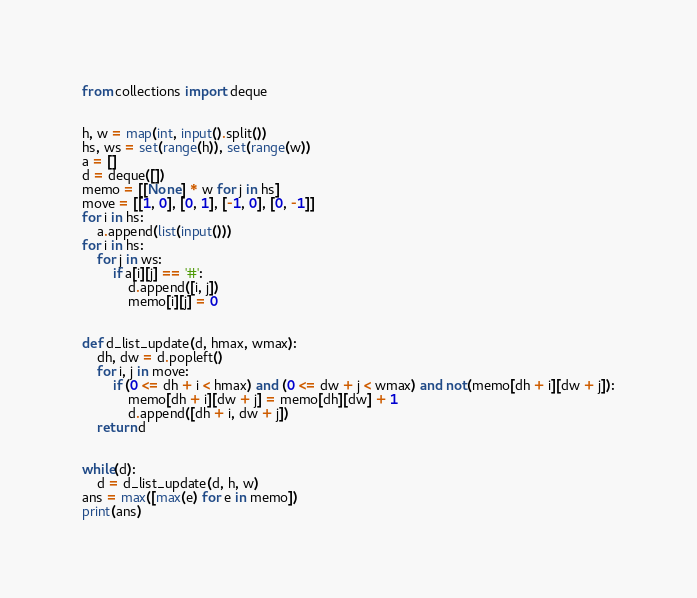Convert code to text. <code><loc_0><loc_0><loc_500><loc_500><_Python_>from collections import deque


h, w = map(int, input().split())
hs, ws = set(range(h)), set(range(w))
a = []
d = deque([])
memo = [[None] * w for j in hs]
move = [[1, 0], [0, 1], [-1, 0], [0, -1]]
for i in hs:
    a.append(list(input()))
for i in hs:
    for j in ws:
        if a[i][j] == '#':
            d.append([i, j])
            memo[i][j] = 0


def d_list_update(d, hmax, wmax):
    dh, dw = d.popleft()
    for i, j in move:
        if (0 <= dh + i < hmax) and (0 <= dw + j < wmax) and not(memo[dh + i][dw + j]):
            memo[dh + i][dw + j] = memo[dh][dw] + 1
            d.append([dh + i, dw + j])
    return d


while(d):
    d = d_list_update(d, h, w)
ans = max([max(e) for e in memo])
print(ans)
</code> 